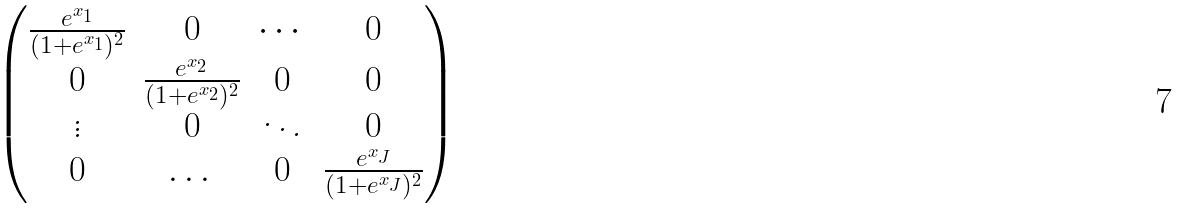Convert formula to latex. <formula><loc_0><loc_0><loc_500><loc_500>\begin{pmatrix} \frac { e ^ { x _ { 1 } } } { ( 1 + e ^ { x _ { 1 } } ) ^ { 2 } } & 0 & \cdots & 0 \\ 0 & \frac { e ^ { x _ { 2 } } } { ( 1 + e ^ { x _ { 2 } } ) ^ { 2 } } & 0 & 0 \\ \vdots & 0 & \ddots & 0 \\ 0 & \dots & 0 & \frac { e ^ { x _ { J } } } { ( 1 + e ^ { x _ { J } } ) ^ { 2 } } \\ \end{pmatrix}</formula> 